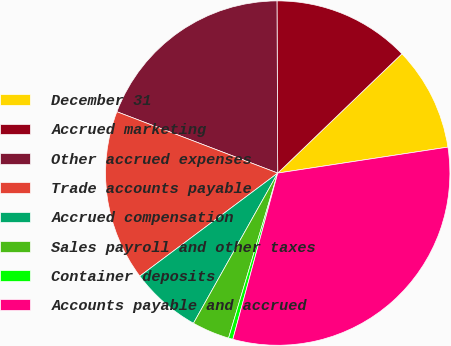<chart> <loc_0><loc_0><loc_500><loc_500><pie_chart><fcel>December 31<fcel>Accrued marketing<fcel>Other accrued expenses<fcel>Trade accounts payable<fcel>Accrued compensation<fcel>Sales payroll and other taxes<fcel>Container deposits<fcel>Accounts payable and accrued<nl><fcel>9.77%<fcel>12.89%<fcel>19.13%<fcel>16.01%<fcel>6.65%<fcel>3.53%<fcel>0.41%<fcel>31.61%<nl></chart> 